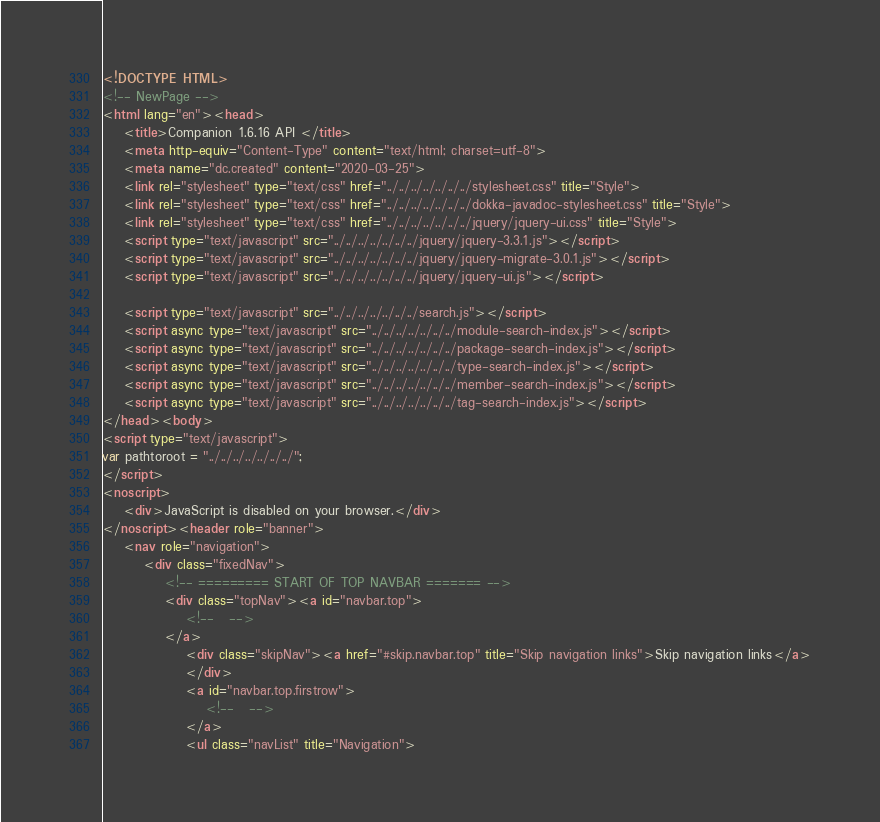<code> <loc_0><loc_0><loc_500><loc_500><_HTML_><!DOCTYPE HTML>
<!-- NewPage -->
<html lang="en"><head>
    <title>Companion 1.6.16 API </title>
    <meta http-equiv="Content-Type" content="text/html; charset=utf-8">
    <meta name="dc.created" content="2020-03-25">
    <link rel="stylesheet" type="text/css" href="../../../../../../../stylesheet.css" title="Style">
    <link rel="stylesheet" type="text/css" href="../../../../../../../dokka-javadoc-stylesheet.css" title="Style">
    <link rel="stylesheet" type="text/css" href="../../../../../../../jquery/jquery-ui.css" title="Style">
    <script type="text/javascript" src="../../../../../../../jquery/jquery-3.3.1.js"></script>
    <script type="text/javascript" src="../../../../../../../jquery/jquery-migrate-3.0.1.js"></script>
    <script type="text/javascript" src="../../../../../../../jquery/jquery-ui.js"></script>

    <script type="text/javascript" src="../../../../../../../search.js"></script>
    <script async type="text/javascript" src="../../../../../../../module-search-index.js"></script>
    <script async type="text/javascript" src="../../../../../../../package-search-index.js"></script>
    <script async type="text/javascript" src="../../../../../../../type-search-index.js"></script>
    <script async type="text/javascript" src="../../../../../../../member-search-index.js"></script>
    <script async type="text/javascript" src="../../../../../../../tag-search-index.js"></script>
</head><body>
<script type="text/javascript">
var pathtoroot = "../../../../../../../";
</script>
<noscript>
    <div>JavaScript is disabled on your browser.</div>
</noscript><header role="banner">
    <nav role="navigation">
        <div class="fixedNav">
            <!-- ========= START OF TOP NAVBAR ======= -->
            <div class="topNav"><a id="navbar.top">
                <!--   -->
            </a>
                <div class="skipNav"><a href="#skip.navbar.top" title="Skip navigation links">Skip navigation links</a>
                </div>
                <a id="navbar.top.firstrow">
                    <!--   -->
                </a>
                <ul class="navList" title="Navigation"></code> 